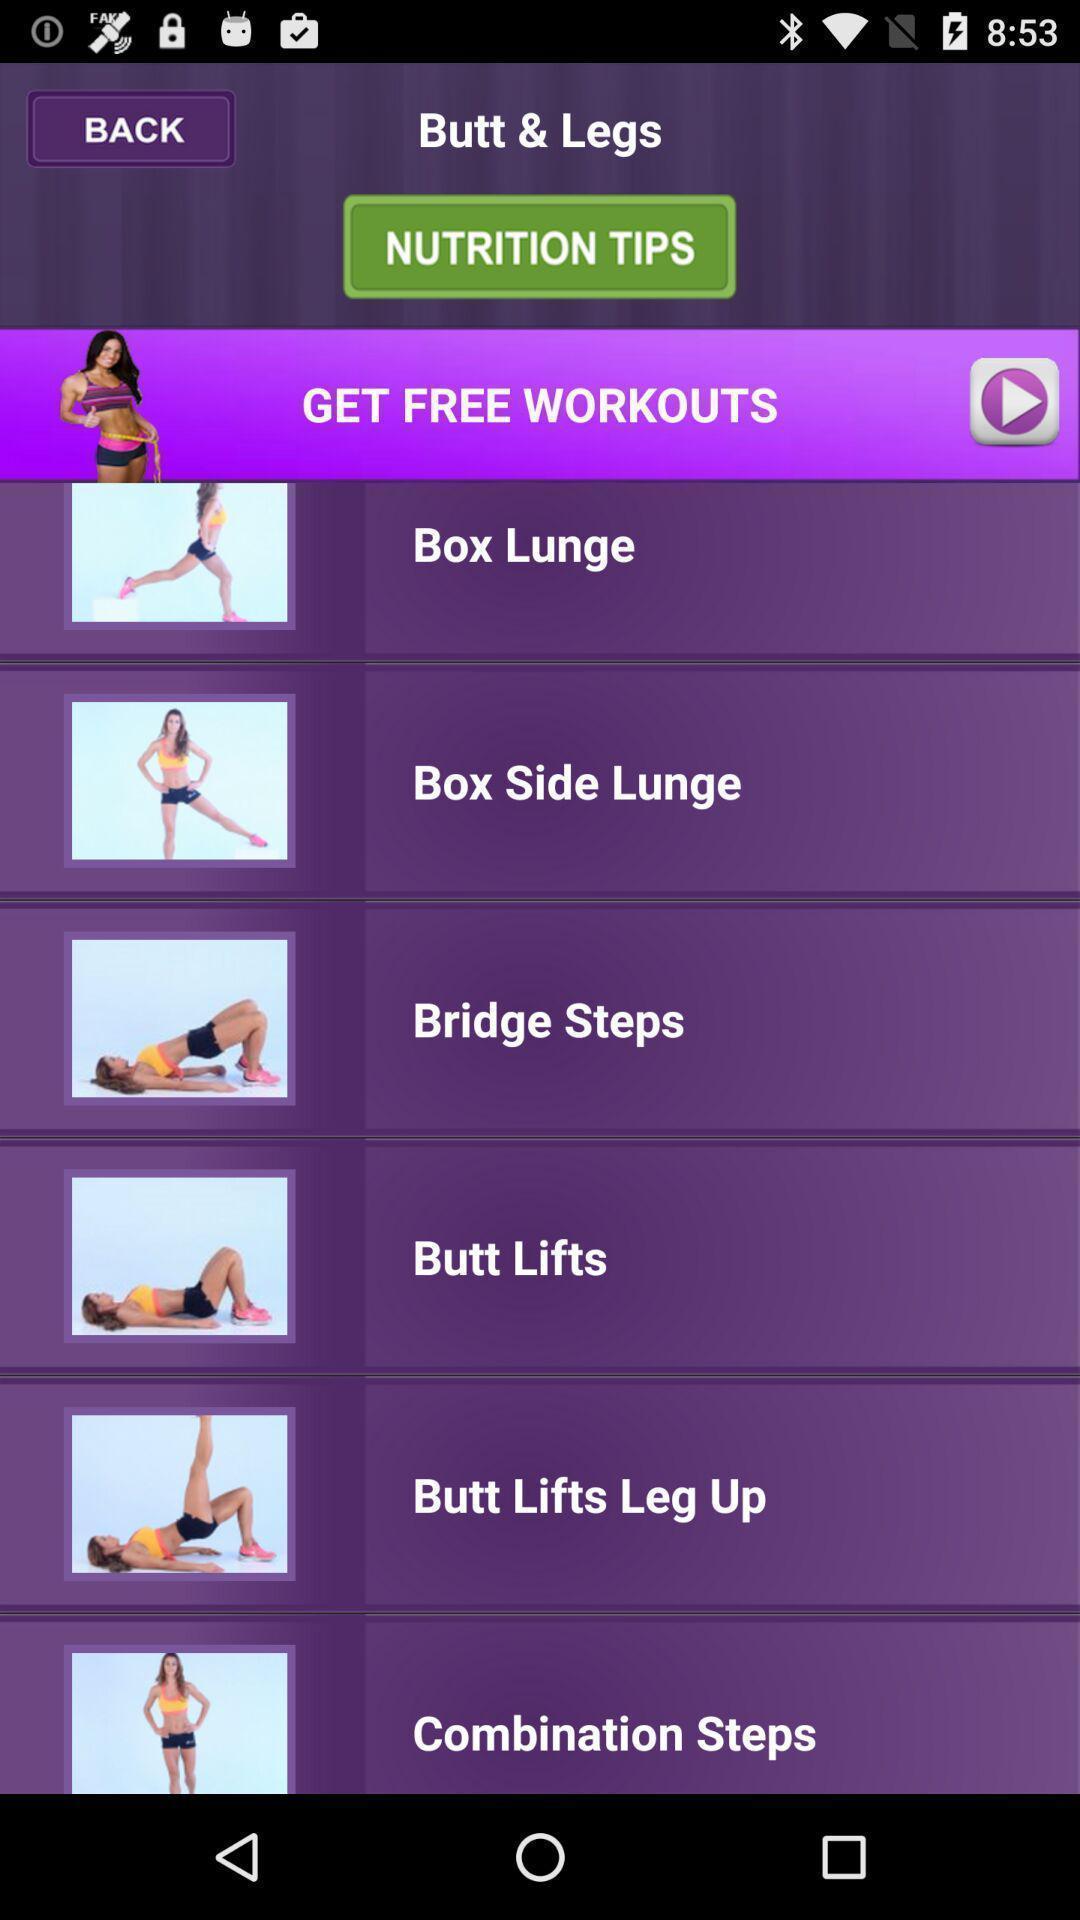Describe the content in this image. Screen displaying the page of a fitness app. 